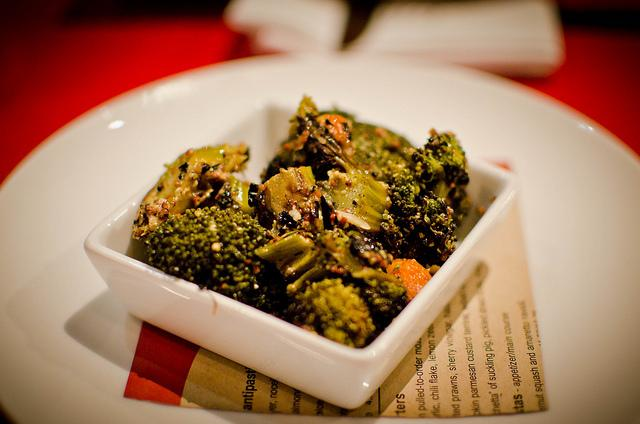What shape is the small plate? Please explain your reasoning. square. The shape is square. 